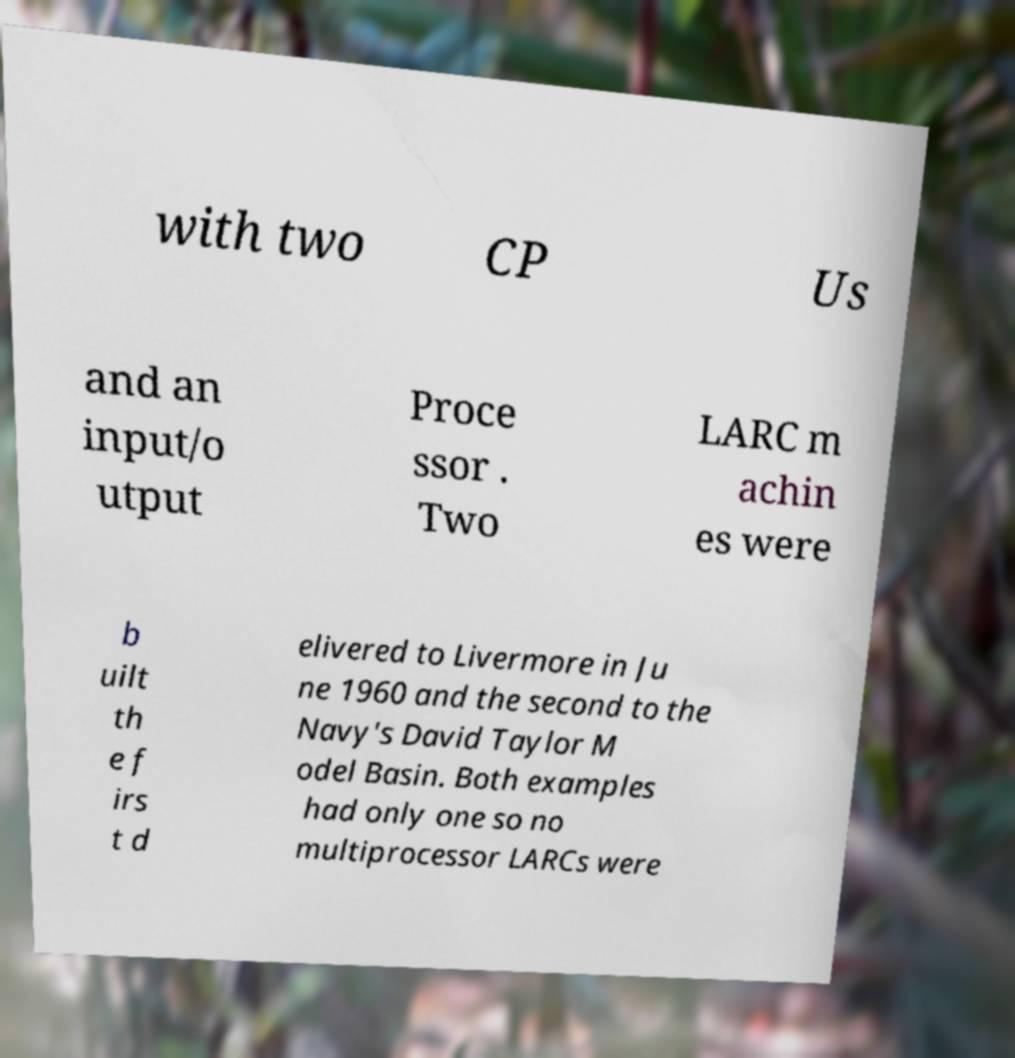There's text embedded in this image that I need extracted. Can you transcribe it verbatim? with two CP Us and an input/o utput Proce ssor . Two LARC m achin es were b uilt th e f irs t d elivered to Livermore in Ju ne 1960 and the second to the Navy's David Taylor M odel Basin. Both examples had only one so no multiprocessor LARCs were 